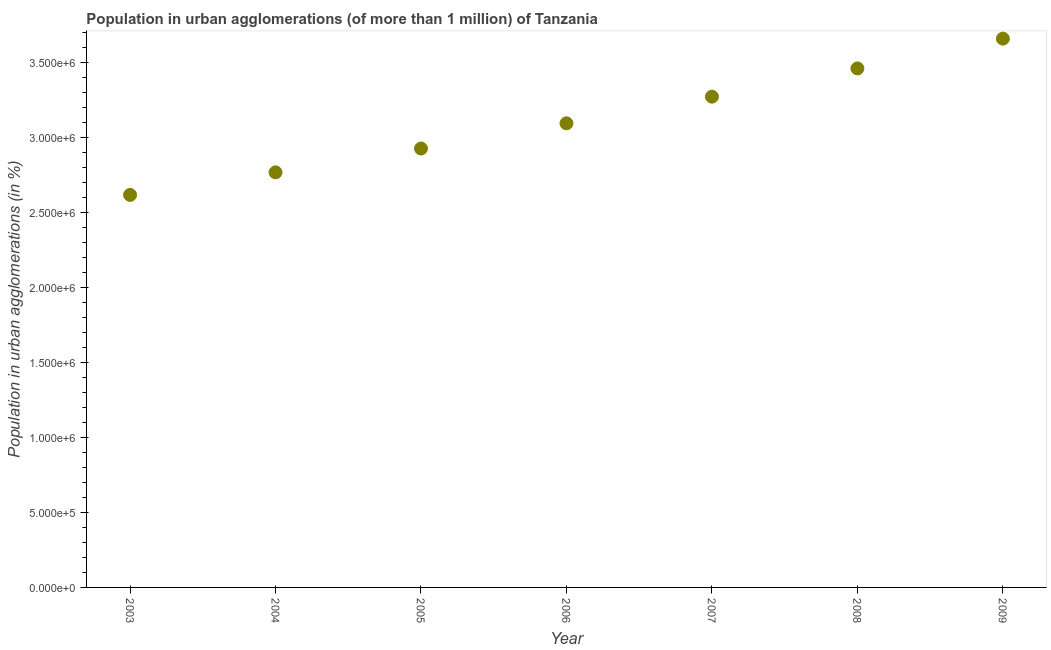What is the population in urban agglomerations in 2003?
Give a very brief answer. 2.62e+06. Across all years, what is the maximum population in urban agglomerations?
Your answer should be very brief. 3.66e+06. Across all years, what is the minimum population in urban agglomerations?
Provide a succinct answer. 2.62e+06. In which year was the population in urban agglomerations maximum?
Keep it short and to the point. 2009. What is the sum of the population in urban agglomerations?
Your answer should be compact. 2.18e+07. What is the difference between the population in urban agglomerations in 2004 and 2007?
Make the answer very short. -5.05e+05. What is the average population in urban agglomerations per year?
Offer a very short reply. 3.11e+06. What is the median population in urban agglomerations?
Keep it short and to the point. 3.09e+06. In how many years, is the population in urban agglomerations greater than 700000 %?
Your answer should be compact. 7. What is the ratio of the population in urban agglomerations in 2005 to that in 2009?
Provide a short and direct response. 0.8. What is the difference between the highest and the second highest population in urban agglomerations?
Make the answer very short. 1.99e+05. What is the difference between the highest and the lowest population in urban agglomerations?
Make the answer very short. 1.04e+06. In how many years, is the population in urban agglomerations greater than the average population in urban agglomerations taken over all years?
Offer a terse response. 3. How many years are there in the graph?
Offer a very short reply. 7. Are the values on the major ticks of Y-axis written in scientific E-notation?
Provide a short and direct response. Yes. Does the graph contain grids?
Offer a terse response. No. What is the title of the graph?
Make the answer very short. Population in urban agglomerations (of more than 1 million) of Tanzania. What is the label or title of the X-axis?
Your response must be concise. Year. What is the label or title of the Y-axis?
Your answer should be very brief. Population in urban agglomerations (in %). What is the Population in urban agglomerations (in %) in 2003?
Ensure brevity in your answer.  2.62e+06. What is the Population in urban agglomerations (in %) in 2004?
Your response must be concise. 2.77e+06. What is the Population in urban agglomerations (in %) in 2005?
Your answer should be very brief. 2.93e+06. What is the Population in urban agglomerations (in %) in 2006?
Provide a short and direct response. 3.09e+06. What is the Population in urban agglomerations (in %) in 2007?
Keep it short and to the point. 3.27e+06. What is the Population in urban agglomerations (in %) in 2008?
Your answer should be compact. 3.46e+06. What is the Population in urban agglomerations (in %) in 2009?
Provide a succinct answer. 3.66e+06. What is the difference between the Population in urban agglomerations (in %) in 2003 and 2004?
Ensure brevity in your answer.  -1.51e+05. What is the difference between the Population in urban agglomerations (in %) in 2003 and 2005?
Offer a terse response. -3.09e+05. What is the difference between the Population in urban agglomerations (in %) in 2003 and 2006?
Give a very brief answer. -4.78e+05. What is the difference between the Population in urban agglomerations (in %) in 2003 and 2007?
Make the answer very short. -6.55e+05. What is the difference between the Population in urban agglomerations (in %) in 2003 and 2008?
Offer a very short reply. -8.44e+05. What is the difference between the Population in urban agglomerations (in %) in 2003 and 2009?
Offer a very short reply. -1.04e+06. What is the difference between the Population in urban agglomerations (in %) in 2004 and 2005?
Offer a terse response. -1.59e+05. What is the difference between the Population in urban agglomerations (in %) in 2004 and 2006?
Keep it short and to the point. -3.27e+05. What is the difference between the Population in urban agglomerations (in %) in 2004 and 2007?
Provide a short and direct response. -5.05e+05. What is the difference between the Population in urban agglomerations (in %) in 2004 and 2008?
Keep it short and to the point. -6.93e+05. What is the difference between the Population in urban agglomerations (in %) in 2004 and 2009?
Offer a terse response. -8.92e+05. What is the difference between the Population in urban agglomerations (in %) in 2005 and 2006?
Your answer should be very brief. -1.68e+05. What is the difference between the Population in urban agglomerations (in %) in 2005 and 2007?
Keep it short and to the point. -3.46e+05. What is the difference between the Population in urban agglomerations (in %) in 2005 and 2008?
Keep it short and to the point. -5.34e+05. What is the difference between the Population in urban agglomerations (in %) in 2005 and 2009?
Your response must be concise. -7.33e+05. What is the difference between the Population in urban agglomerations (in %) in 2006 and 2007?
Make the answer very short. -1.78e+05. What is the difference between the Population in urban agglomerations (in %) in 2006 and 2008?
Your answer should be compact. -3.66e+05. What is the difference between the Population in urban agglomerations (in %) in 2006 and 2009?
Keep it short and to the point. -5.65e+05. What is the difference between the Population in urban agglomerations (in %) in 2007 and 2008?
Your answer should be compact. -1.88e+05. What is the difference between the Population in urban agglomerations (in %) in 2007 and 2009?
Keep it short and to the point. -3.87e+05. What is the difference between the Population in urban agglomerations (in %) in 2008 and 2009?
Your response must be concise. -1.99e+05. What is the ratio of the Population in urban agglomerations (in %) in 2003 to that in 2004?
Your response must be concise. 0.95. What is the ratio of the Population in urban agglomerations (in %) in 2003 to that in 2005?
Make the answer very short. 0.89. What is the ratio of the Population in urban agglomerations (in %) in 2003 to that in 2006?
Your answer should be very brief. 0.85. What is the ratio of the Population in urban agglomerations (in %) in 2003 to that in 2008?
Provide a succinct answer. 0.76. What is the ratio of the Population in urban agglomerations (in %) in 2003 to that in 2009?
Your response must be concise. 0.71. What is the ratio of the Population in urban agglomerations (in %) in 2004 to that in 2005?
Offer a terse response. 0.95. What is the ratio of the Population in urban agglomerations (in %) in 2004 to that in 2006?
Make the answer very short. 0.89. What is the ratio of the Population in urban agglomerations (in %) in 2004 to that in 2007?
Give a very brief answer. 0.85. What is the ratio of the Population in urban agglomerations (in %) in 2004 to that in 2008?
Offer a very short reply. 0.8. What is the ratio of the Population in urban agglomerations (in %) in 2004 to that in 2009?
Provide a short and direct response. 0.76. What is the ratio of the Population in urban agglomerations (in %) in 2005 to that in 2006?
Provide a succinct answer. 0.95. What is the ratio of the Population in urban agglomerations (in %) in 2005 to that in 2007?
Provide a short and direct response. 0.89. What is the ratio of the Population in urban agglomerations (in %) in 2005 to that in 2008?
Keep it short and to the point. 0.85. What is the ratio of the Population in urban agglomerations (in %) in 2005 to that in 2009?
Your answer should be compact. 0.8. What is the ratio of the Population in urban agglomerations (in %) in 2006 to that in 2007?
Your answer should be very brief. 0.95. What is the ratio of the Population in urban agglomerations (in %) in 2006 to that in 2008?
Offer a very short reply. 0.89. What is the ratio of the Population in urban agglomerations (in %) in 2006 to that in 2009?
Provide a short and direct response. 0.85. What is the ratio of the Population in urban agglomerations (in %) in 2007 to that in 2008?
Your answer should be very brief. 0.95. What is the ratio of the Population in urban agglomerations (in %) in 2007 to that in 2009?
Keep it short and to the point. 0.89. What is the ratio of the Population in urban agglomerations (in %) in 2008 to that in 2009?
Your answer should be compact. 0.95. 